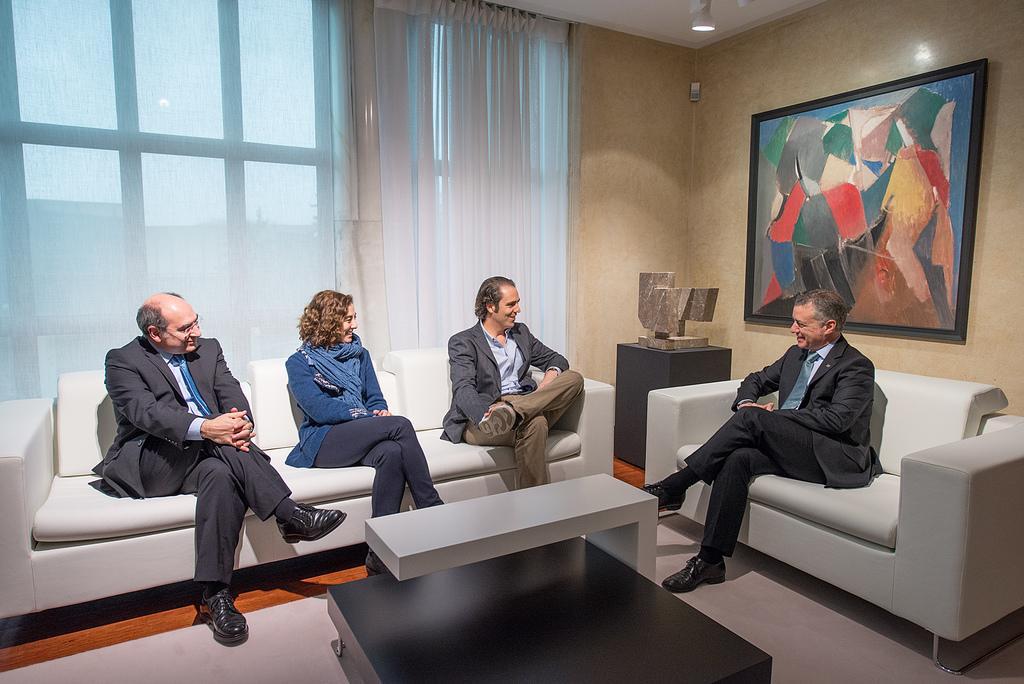Describe this image in one or two sentences. In the image there are two white color sofas, on the first sofa there are three people sitting , on the second sofa there is a man sitting , in front of them there is a table,behind the sofa there is a wall, on the wall there is a photo frame, in the background there are white color curtains, behind it there is a window. 